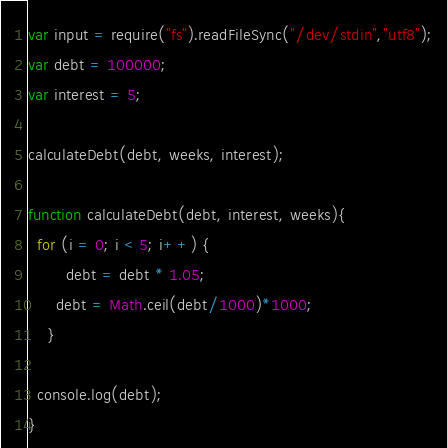<code> <loc_0><loc_0><loc_500><loc_500><_JavaScript_>var input = require("fs").readFileSync("/dev/stdin","utf8");
var debt = 100000;
var interest = 5;

calculateDebt(debt, weeks, interest);

function calculateDebt(debt, interest, weeks){
  for (i = 0; i < 5; i++) { 
    	debt = debt * 1.05;
      debt = Math.ceil(debt/1000)*1000;
	}
  
  console.log(debt);
}</code> 